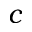<formula> <loc_0><loc_0><loc_500><loc_500>c</formula> 